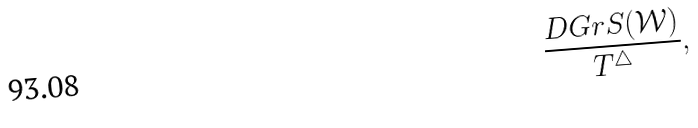Convert formula to latex. <formula><loc_0><loc_0><loc_500><loc_500>\frac { D G r S ( \mathcal { W } ) } { T ^ { \triangle } } ,</formula> 